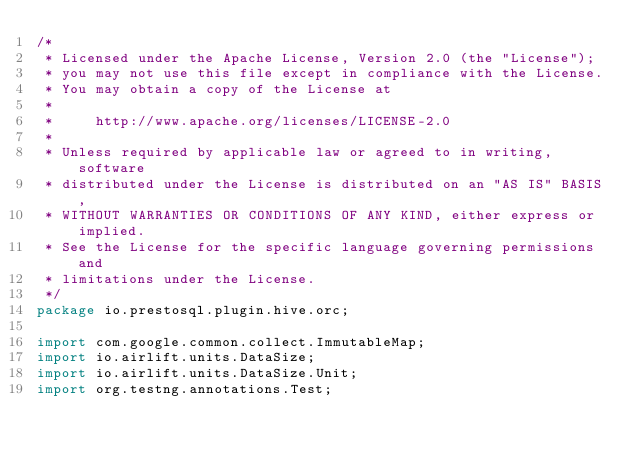Convert code to text. <code><loc_0><loc_0><loc_500><loc_500><_Java_>/*
 * Licensed under the Apache License, Version 2.0 (the "License");
 * you may not use this file except in compliance with the License.
 * You may obtain a copy of the License at
 *
 *     http://www.apache.org/licenses/LICENSE-2.0
 *
 * Unless required by applicable law or agreed to in writing, software
 * distributed under the License is distributed on an "AS IS" BASIS,
 * WITHOUT WARRANTIES OR CONDITIONS OF ANY KIND, either express or implied.
 * See the License for the specific language governing permissions and
 * limitations under the License.
 */
package io.prestosql.plugin.hive.orc;

import com.google.common.collect.ImmutableMap;
import io.airlift.units.DataSize;
import io.airlift.units.DataSize.Unit;
import org.testng.annotations.Test;
</code> 